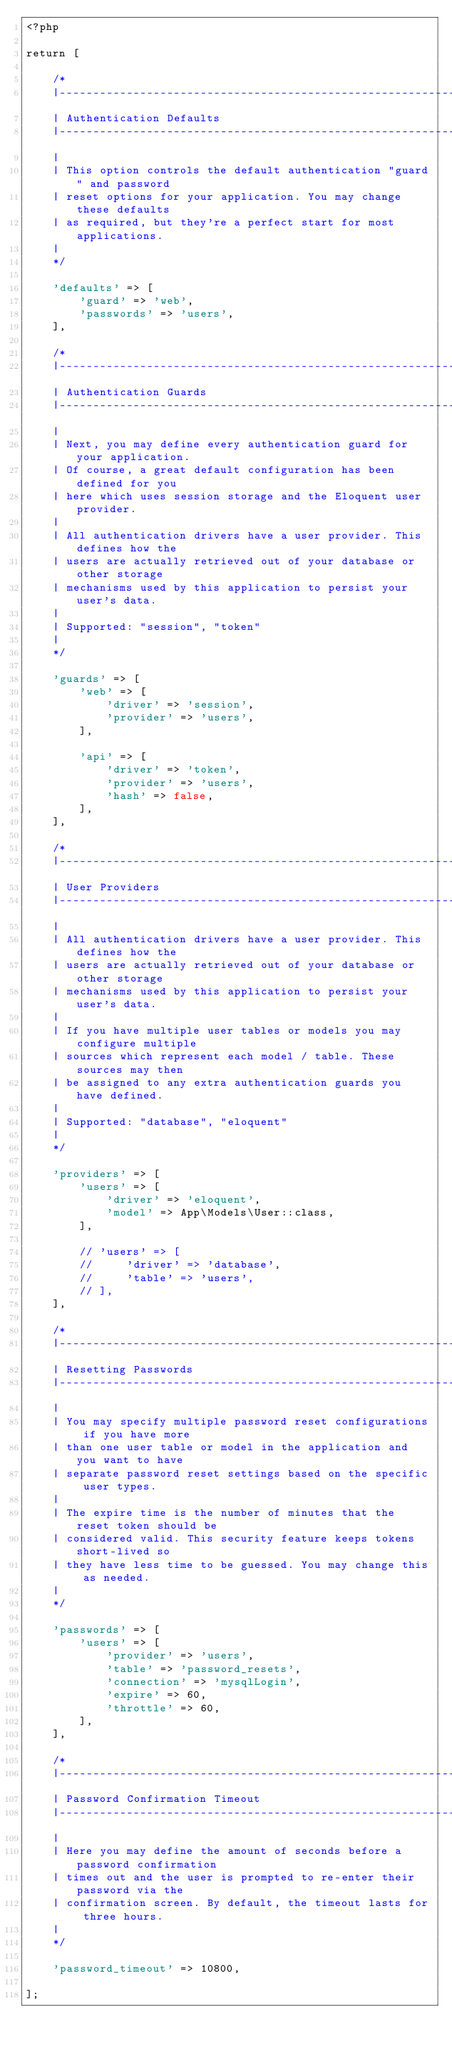Convert code to text. <code><loc_0><loc_0><loc_500><loc_500><_PHP_><?php

return [

    /*
    |--------------------------------------------------------------------------
    | Authentication Defaults
    |--------------------------------------------------------------------------
    |
    | This option controls the default authentication "guard" and password
    | reset options for your application. You may change these defaults
    | as required, but they're a perfect start for most applications.
    |
    */

    'defaults' => [
        'guard' => 'web',
        'passwords' => 'users',
    ],

    /*
    |--------------------------------------------------------------------------
    | Authentication Guards
    |--------------------------------------------------------------------------
    |
    | Next, you may define every authentication guard for your application.
    | Of course, a great default configuration has been defined for you
    | here which uses session storage and the Eloquent user provider.
    |
    | All authentication drivers have a user provider. This defines how the
    | users are actually retrieved out of your database or other storage
    | mechanisms used by this application to persist your user's data.
    |
    | Supported: "session", "token"
    |
    */

    'guards' => [
        'web' => [
            'driver' => 'session',
            'provider' => 'users',
        ],

        'api' => [
            'driver' => 'token',
            'provider' => 'users',
            'hash' => false,
        ],
    ],

    /*
    |--------------------------------------------------------------------------
    | User Providers
    |--------------------------------------------------------------------------
    |
    | All authentication drivers have a user provider. This defines how the
    | users are actually retrieved out of your database or other storage
    | mechanisms used by this application to persist your user's data.
    |
    | If you have multiple user tables or models you may configure multiple
    | sources which represent each model / table. These sources may then
    | be assigned to any extra authentication guards you have defined.
    |
    | Supported: "database", "eloquent"
    |
    */

    'providers' => [
        'users' => [
            'driver' => 'eloquent',
            'model' => App\Models\User::class,
        ],

        // 'users' => [
        //     'driver' => 'database',
        //     'table' => 'users',
        // ],
    ],

    /*
    |--------------------------------------------------------------------------
    | Resetting Passwords
    |--------------------------------------------------------------------------
    |
    | You may specify multiple password reset configurations if you have more
    | than one user table or model in the application and you want to have
    | separate password reset settings based on the specific user types.
    |
    | The expire time is the number of minutes that the reset token should be
    | considered valid. This security feature keeps tokens short-lived so
    | they have less time to be guessed. You may change this as needed.
    |
    */

    'passwords' => [
        'users' => [
            'provider' => 'users',
            'table' => 'password_resets',
            'connection' => 'mysqlLogin',
            'expire' => 60,
            'throttle' => 60,
        ],
    ],

    /*
    |--------------------------------------------------------------------------
    | Password Confirmation Timeout
    |--------------------------------------------------------------------------
    |
    | Here you may define the amount of seconds before a password confirmation
    | times out and the user is prompted to re-enter their password via the
    | confirmation screen. By default, the timeout lasts for three hours.
    |
    */

    'password_timeout' => 10800,

];
</code> 